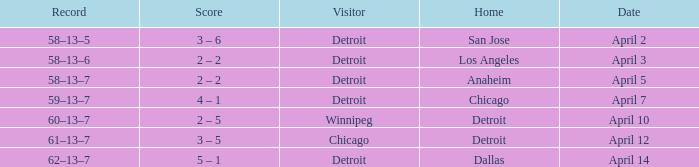Who was the home team in the game having a visitor of Chicago? Detroit. 